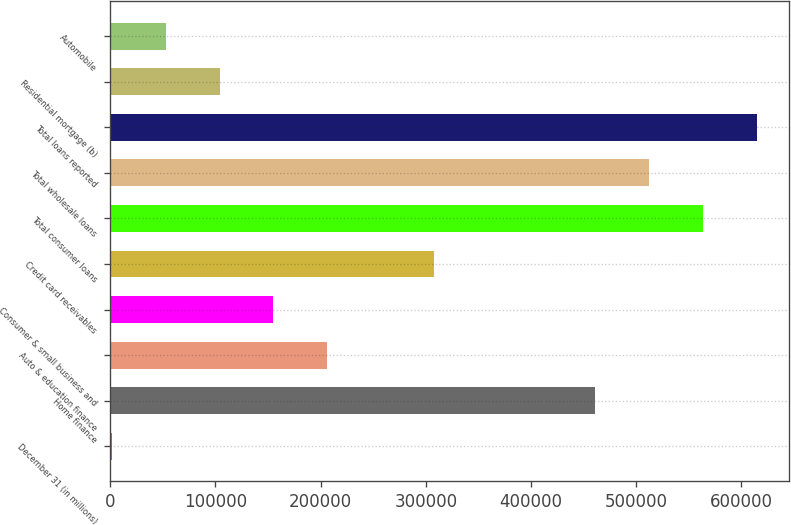Convert chart to OTSL. <chart><loc_0><loc_0><loc_500><loc_500><bar_chart><fcel>December 31 (in millions)<fcel>Home finance<fcel>Auto & education finance<fcel>Consumer & small business and<fcel>Credit card receivables<fcel>Total consumer loans<fcel>Total wholesale loans<fcel>Total loans reported<fcel>Residential mortgage (b)<fcel>Automobile<nl><fcel>2005<fcel>461202<fcel>206093<fcel>155071<fcel>308136<fcel>563246<fcel>512224<fcel>614268<fcel>104049<fcel>53026.9<nl></chart> 